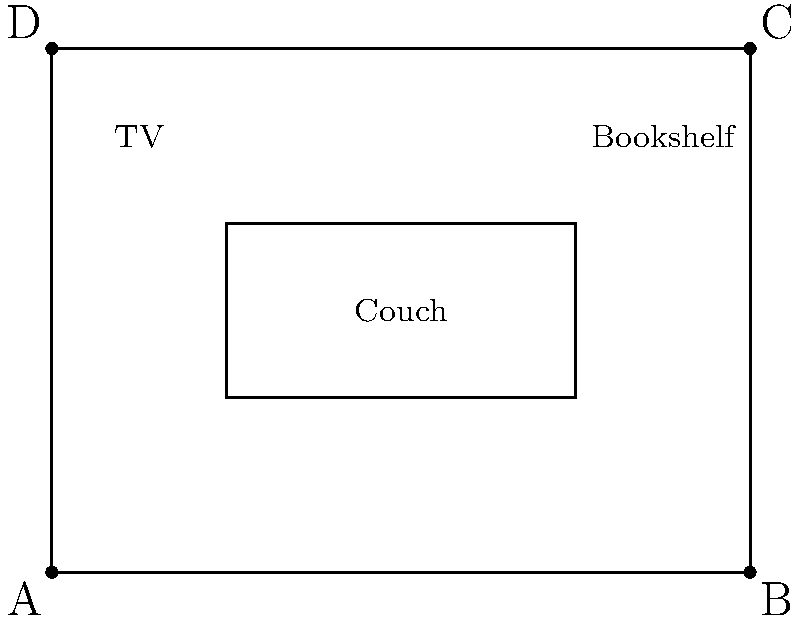In the Tanner family's attic, DJ wants to rearrange the furniture. The diagram shows the initial layout of the room and furniture. She wants to rotate the couch 90° clockwise around point A, reflect the TV across the line AB, and translate the bookshelf 2 units left and 1 unit down. What will be the new coordinates of point G (the top-right corner of the couch) after these transformations? Let's approach this step-by-step:

1) Rotating the couch 90° clockwise around point A:
   - The couch's original coordinates are E(1,1), F(3,1), G(3,2), H(1,2)
   - After rotation, E stays at (1,1), F moves to (1,3), G moves to (0,3), and H moves to (0,1)
   - We're interested in G, which is now at (0,3)

2) Reflecting the TV across line AB:
   - This doesn't affect the couch, so G remains at (0,3)

3) Translating the bookshelf:
   - This also doesn't affect the couch, so G still remains at (0,3)

Therefore, after all transformations, point G (the top-right corner of the couch) will be at coordinates (0,3).
Answer: (0,3) 